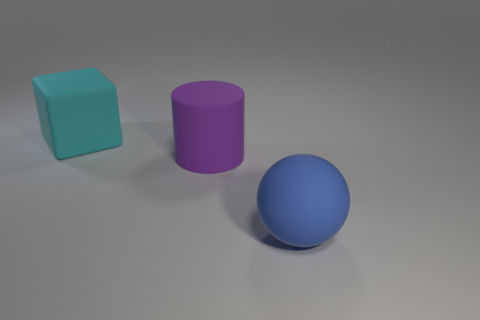Comment on the color choices for the objects. The color choices for the objects include cyan for the cube, violet for the cylinder, and blue for the sphere. These colors are distinct yet harmonious, likely chosen to provide visual contrast while maintaining an overall cohesive feel to the palette used in the scene. 